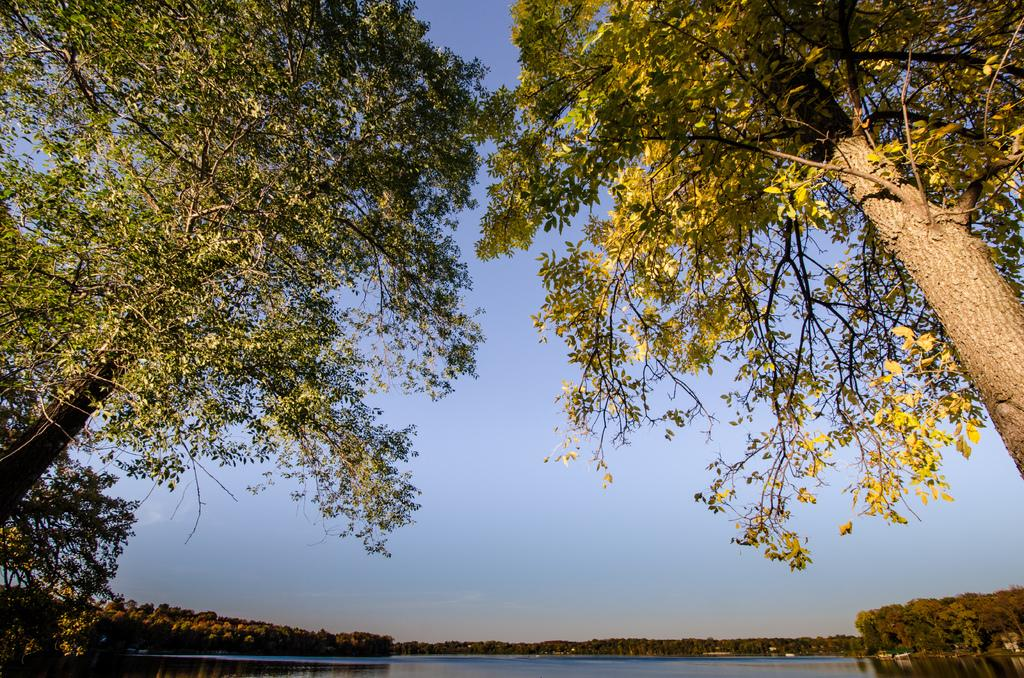What type of vegetation is present in the image? There are many trees in the image. What body of water can be seen at the bottom of the image? There is a lake at the bottom of the image. What part of the natural environment is visible in the image? The sky is visible in the image. Can you tell me how many kittens are playing near the lake in the image? There are no kittens present in the image; it features trees, a lake, and the sky. What type of animal is coughing in the image? There is no animal coughing in the image; it features trees, a lake, and the sky. 